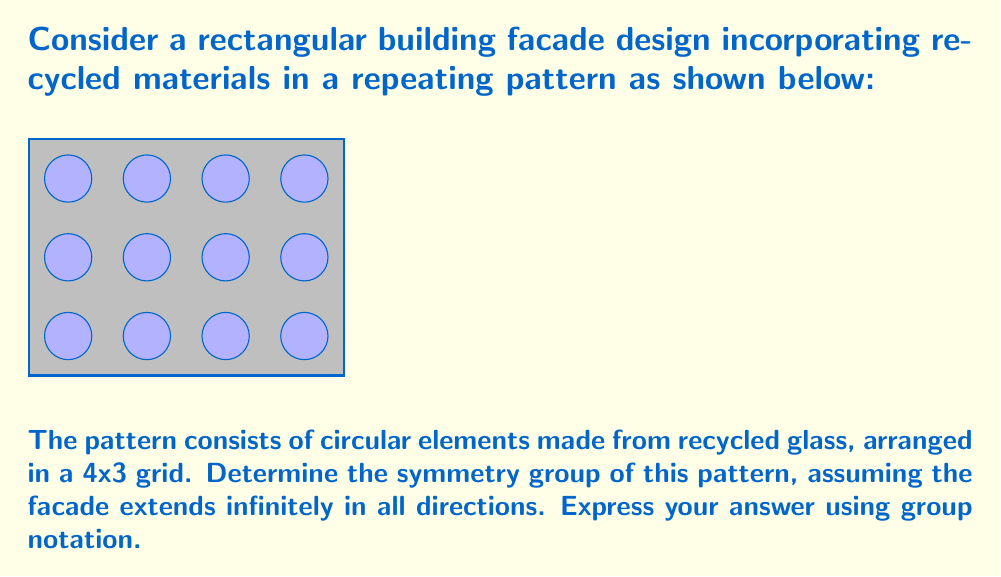Provide a solution to this math problem. To determine the symmetry group of this pattern, we need to identify all symmetry operations that leave the pattern unchanged. Let's consider each type of symmetry:

1. Translations:
   - Horizontal translation by 4 units: $T_h$
   - Vertical translation by 3 units: $T_v$

2. Rotations:
   - 180° rotation around the center of each circle: $R_{180}$
   - 180° rotation around the midpoint of each edge between circles: $R'_{180}$

3. Reflections:
   - Horizontal reflections through the middle of each row: $M_h$
   - Vertical reflections through the middle of each column: $M_v$
   - Diagonal reflections through the centers of circles: $M_d$ and $M'_d$

The symmetry group of this pattern is a wallpaper group. Based on the symmetries identified, we can determine that this is the p2mm group in the crystallographic notation.

The group structure can be expressed as:

$$G = \{T_h^n T_v^m R_{180}^i R'_{180}^j M_h^k M_v^l M_d^p M'_d^q | n,m \in \mathbb{Z}; i,j,k,l,p,q \in \{0,1}\}$$

This group is isomorphic to the direct product of two infinite cyclic groups (for translations) and four cyclic groups of order 2 (for rotations and reflections):

$$G \cong \mathbb{Z} \times \mathbb{Z} \times C_2 \times C_2 \times C_2 \times C_2$$

Where $\mathbb{Z}$ represents the infinite cyclic group and $C_2$ represents the cyclic group of order 2.
Answer: p2mm $\cong \mathbb{Z} \times \mathbb{Z} \times C_2 \times C_2 \times C_2 \times C_2$ 